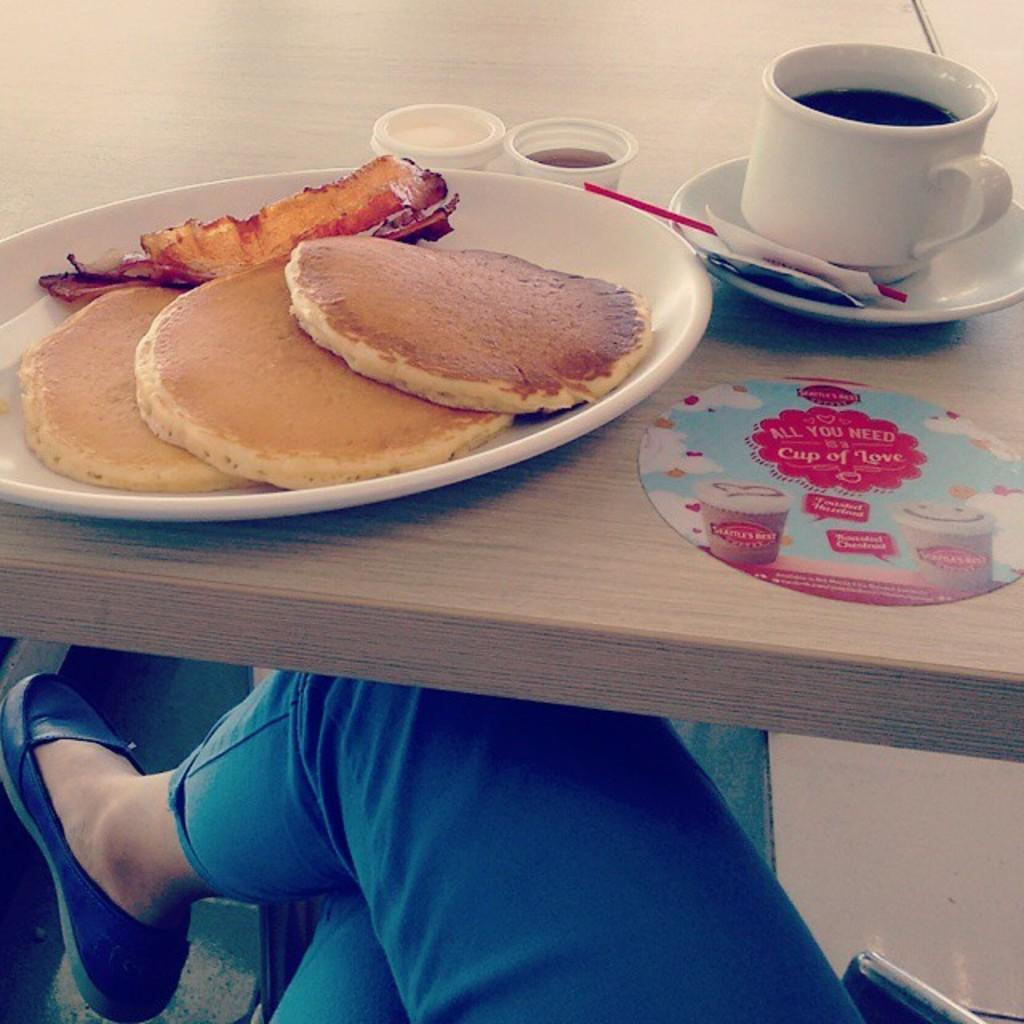What piece of furniture is present in the image? There is a table in the image. What is on the table? There is a plate with a food item, a cup with a drink, a saucer, a stick, and packets on the table. What is the person sitting near the table doing? The person's actions are not specified in the image. Can you describe the drink in the cup? The details of the drink are not provided in the image. What type of substance is the wren using to aid its digestion in the image? There is no wren or substance related to digestion present in the image. 